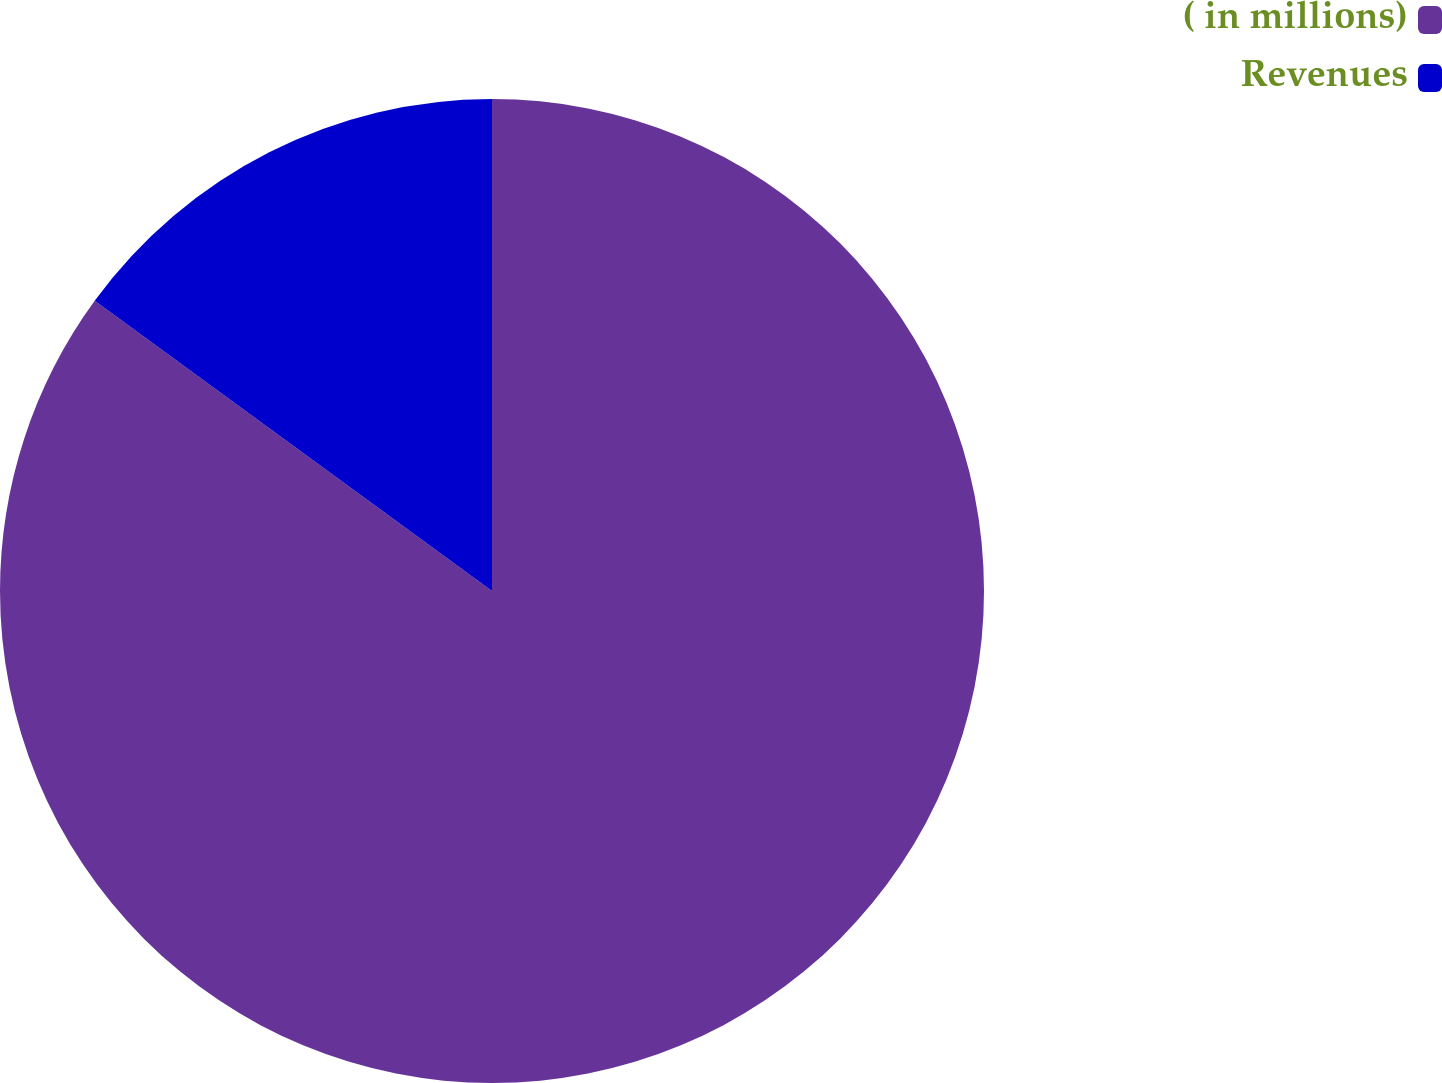<chart> <loc_0><loc_0><loc_500><loc_500><pie_chart><fcel>( in millions)<fcel>Revenues<nl><fcel>85.04%<fcel>14.96%<nl></chart> 